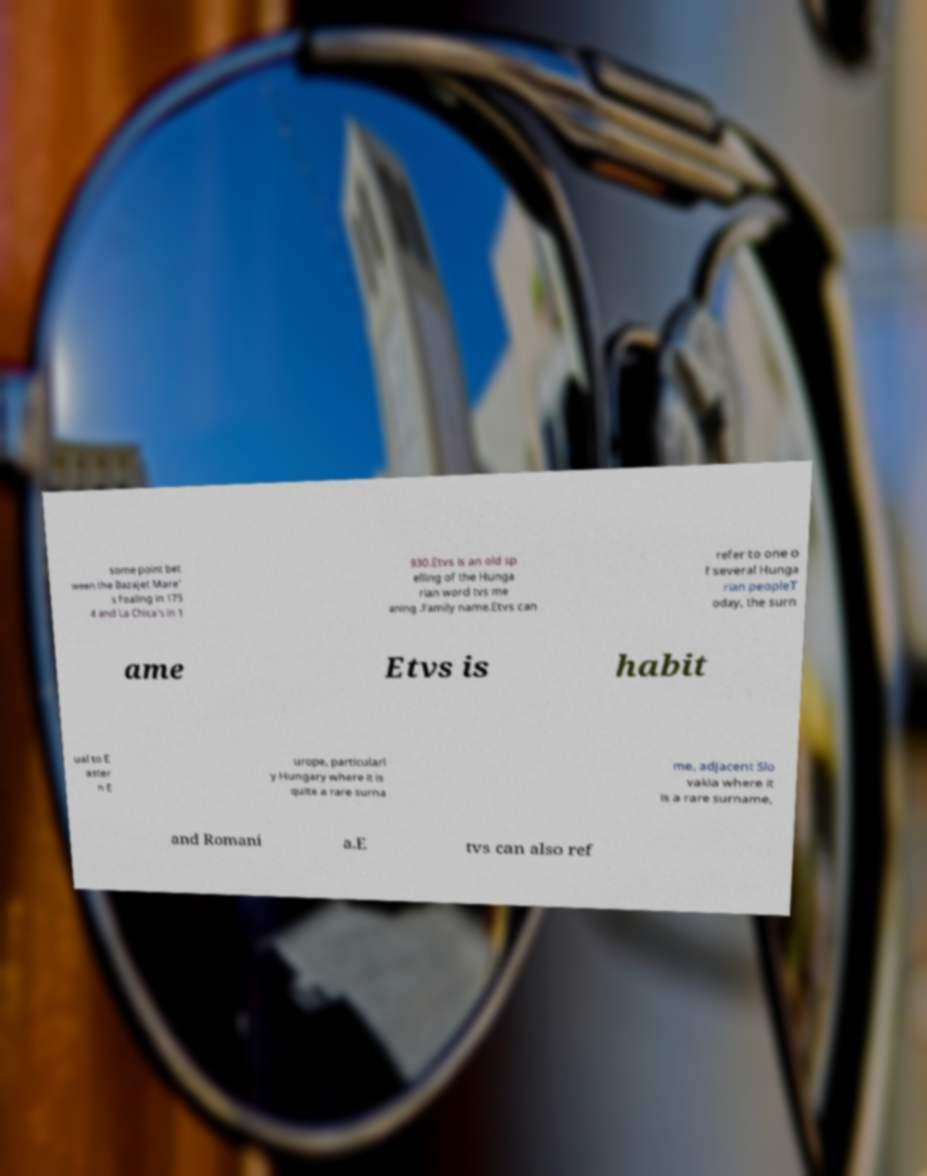Could you extract and type out the text from this image? some point bet ween the Bazajet Mare' s foaling in 175 4 and La Chica's in 1 930.Etvs is an old sp elling of the Hunga rian word tvs me aning .Family name.Etvs can refer to one o f several Hunga rian peopleT oday, the surn ame Etvs is habit ual to E aster n E urope, particularl y Hungary where it is quite a rare surna me, adjacent Slo vakia where it is a rare surname, and Romani a.E tvs can also ref 